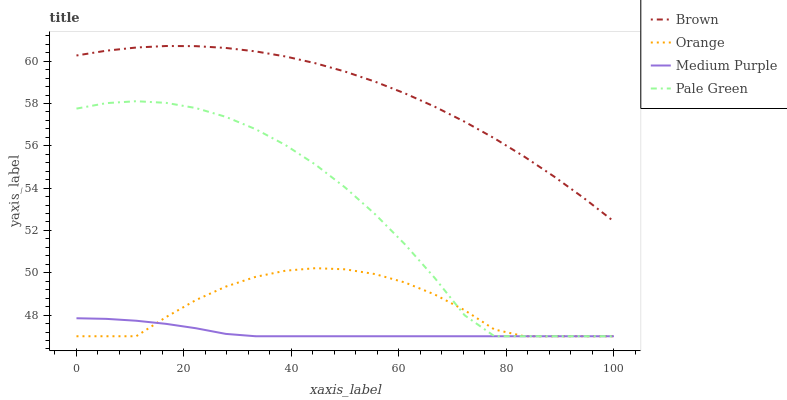Does Brown have the minimum area under the curve?
Answer yes or no. No. Does Medium Purple have the maximum area under the curve?
Answer yes or no. No. Is Brown the smoothest?
Answer yes or no. No. Is Brown the roughest?
Answer yes or no. No. Does Brown have the lowest value?
Answer yes or no. No. Does Medium Purple have the highest value?
Answer yes or no. No. Is Pale Green less than Brown?
Answer yes or no. Yes. Is Brown greater than Pale Green?
Answer yes or no. Yes. Does Pale Green intersect Brown?
Answer yes or no. No. 